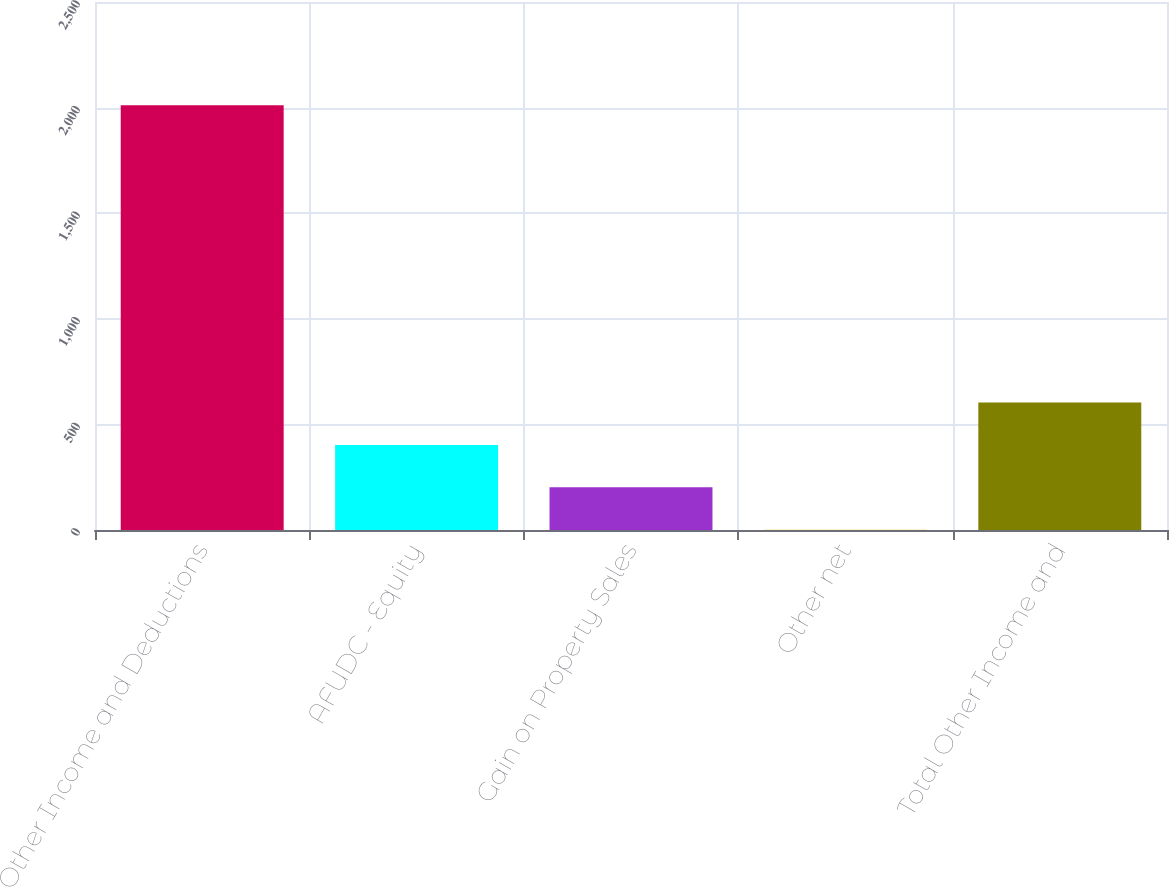Convert chart to OTSL. <chart><loc_0><loc_0><loc_500><loc_500><bar_chart><fcel>Other Income and Deductions<fcel>AFUDC - Equity<fcel>Gain on Property Sales<fcel>Other net<fcel>Total Other Income and<nl><fcel>2011<fcel>402.92<fcel>201.91<fcel>0.9<fcel>603.93<nl></chart> 